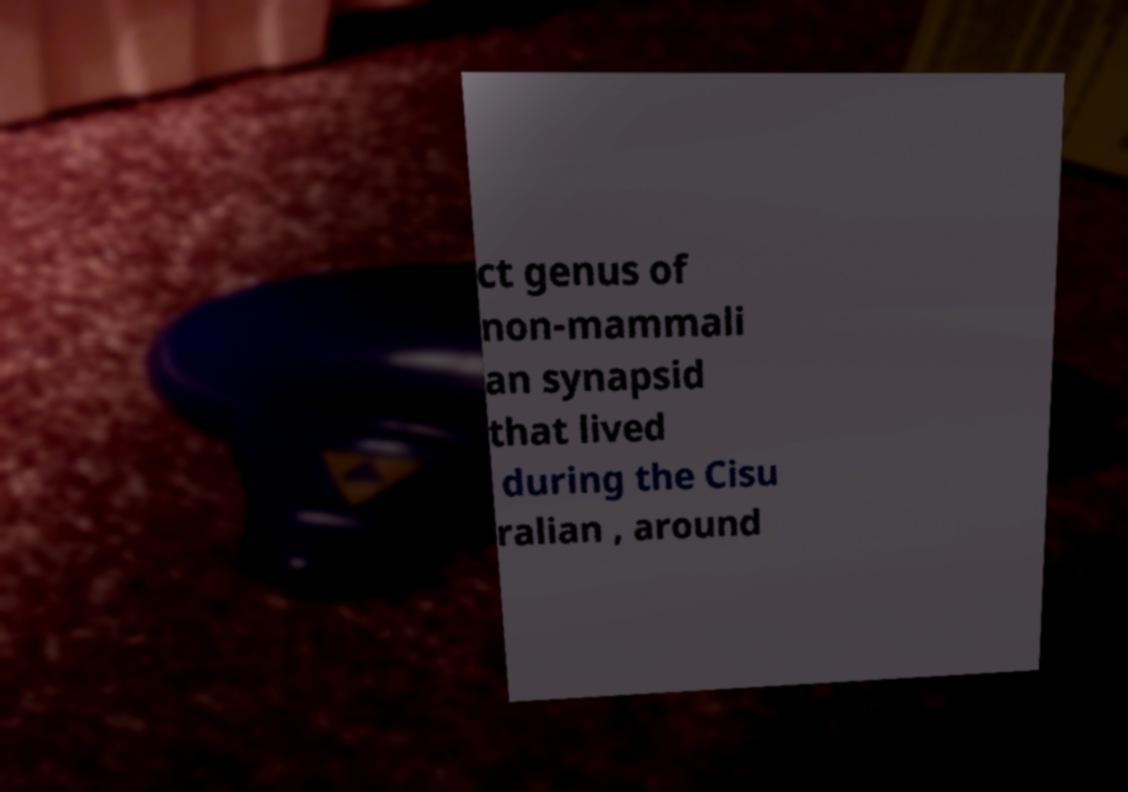Please read and relay the text visible in this image. What does it say? ct genus of non-mammali an synapsid that lived during the Cisu ralian , around 